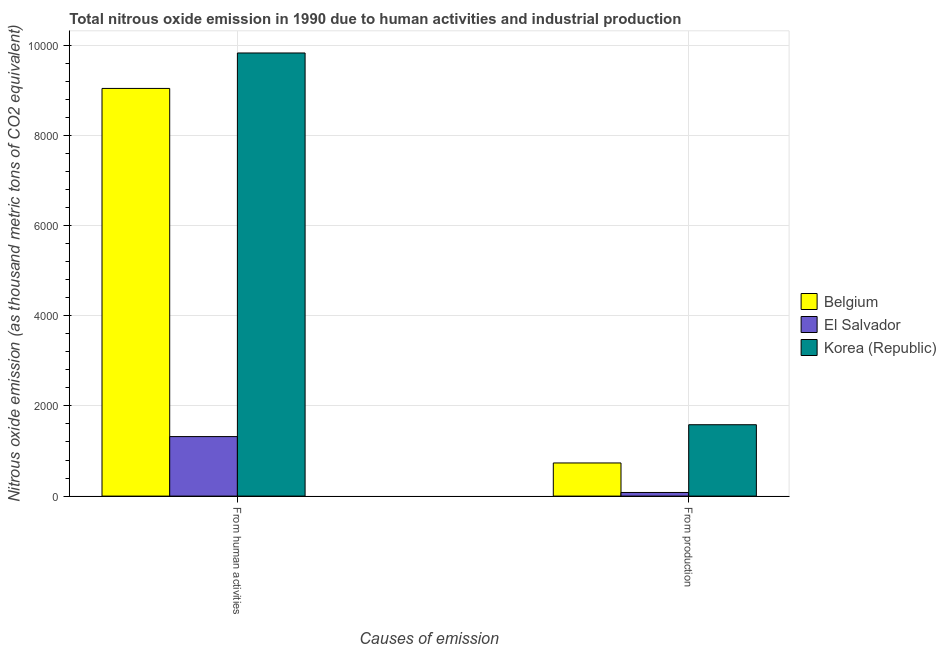How many different coloured bars are there?
Your response must be concise. 3. Are the number of bars on each tick of the X-axis equal?
Provide a succinct answer. Yes. What is the label of the 2nd group of bars from the left?
Provide a short and direct response. From production. What is the amount of emissions from human activities in El Salvador?
Offer a very short reply. 1319.4. Across all countries, what is the maximum amount of emissions from human activities?
Your answer should be very brief. 9823.4. Across all countries, what is the minimum amount of emissions generated from industries?
Offer a very short reply. 80.5. In which country was the amount of emissions from human activities minimum?
Provide a short and direct response. El Salvador. What is the total amount of emissions generated from industries in the graph?
Provide a short and direct response. 2398. What is the difference between the amount of emissions generated from industries in Belgium and that in El Salvador?
Give a very brief answer. 654.4. What is the difference between the amount of emissions generated from industries in Korea (Republic) and the amount of emissions from human activities in El Salvador?
Offer a very short reply. 263.2. What is the average amount of emissions generated from industries per country?
Keep it short and to the point. 799.33. What is the difference between the amount of emissions from human activities and amount of emissions generated from industries in Belgium?
Ensure brevity in your answer.  8302.8. What is the ratio of the amount of emissions generated from industries in Korea (Republic) to that in Belgium?
Ensure brevity in your answer.  2.15. In how many countries, is the amount of emissions from human activities greater than the average amount of emissions from human activities taken over all countries?
Provide a succinct answer. 2. What does the 3rd bar from the right in From human activities represents?
Make the answer very short. Belgium. Are all the bars in the graph horizontal?
Give a very brief answer. No. What is the difference between two consecutive major ticks on the Y-axis?
Make the answer very short. 2000. Are the values on the major ticks of Y-axis written in scientific E-notation?
Your answer should be compact. No. Does the graph contain any zero values?
Keep it short and to the point. No. How many legend labels are there?
Your response must be concise. 3. How are the legend labels stacked?
Your answer should be very brief. Vertical. What is the title of the graph?
Make the answer very short. Total nitrous oxide emission in 1990 due to human activities and industrial production. Does "Belarus" appear as one of the legend labels in the graph?
Keep it short and to the point. No. What is the label or title of the X-axis?
Make the answer very short. Causes of emission. What is the label or title of the Y-axis?
Provide a succinct answer. Nitrous oxide emission (as thousand metric tons of CO2 equivalent). What is the Nitrous oxide emission (as thousand metric tons of CO2 equivalent) of Belgium in From human activities?
Ensure brevity in your answer.  9037.7. What is the Nitrous oxide emission (as thousand metric tons of CO2 equivalent) of El Salvador in From human activities?
Your response must be concise. 1319.4. What is the Nitrous oxide emission (as thousand metric tons of CO2 equivalent) in Korea (Republic) in From human activities?
Ensure brevity in your answer.  9823.4. What is the Nitrous oxide emission (as thousand metric tons of CO2 equivalent) of Belgium in From production?
Ensure brevity in your answer.  734.9. What is the Nitrous oxide emission (as thousand metric tons of CO2 equivalent) of El Salvador in From production?
Your answer should be very brief. 80.5. What is the Nitrous oxide emission (as thousand metric tons of CO2 equivalent) in Korea (Republic) in From production?
Your answer should be very brief. 1582.6. Across all Causes of emission, what is the maximum Nitrous oxide emission (as thousand metric tons of CO2 equivalent) in Belgium?
Make the answer very short. 9037.7. Across all Causes of emission, what is the maximum Nitrous oxide emission (as thousand metric tons of CO2 equivalent) in El Salvador?
Offer a very short reply. 1319.4. Across all Causes of emission, what is the maximum Nitrous oxide emission (as thousand metric tons of CO2 equivalent) in Korea (Republic)?
Keep it short and to the point. 9823.4. Across all Causes of emission, what is the minimum Nitrous oxide emission (as thousand metric tons of CO2 equivalent) of Belgium?
Offer a very short reply. 734.9. Across all Causes of emission, what is the minimum Nitrous oxide emission (as thousand metric tons of CO2 equivalent) of El Salvador?
Your answer should be very brief. 80.5. Across all Causes of emission, what is the minimum Nitrous oxide emission (as thousand metric tons of CO2 equivalent) in Korea (Republic)?
Provide a succinct answer. 1582.6. What is the total Nitrous oxide emission (as thousand metric tons of CO2 equivalent) in Belgium in the graph?
Provide a succinct answer. 9772.6. What is the total Nitrous oxide emission (as thousand metric tons of CO2 equivalent) of El Salvador in the graph?
Offer a terse response. 1399.9. What is the total Nitrous oxide emission (as thousand metric tons of CO2 equivalent) in Korea (Republic) in the graph?
Your answer should be very brief. 1.14e+04. What is the difference between the Nitrous oxide emission (as thousand metric tons of CO2 equivalent) of Belgium in From human activities and that in From production?
Ensure brevity in your answer.  8302.8. What is the difference between the Nitrous oxide emission (as thousand metric tons of CO2 equivalent) in El Salvador in From human activities and that in From production?
Offer a terse response. 1238.9. What is the difference between the Nitrous oxide emission (as thousand metric tons of CO2 equivalent) of Korea (Republic) in From human activities and that in From production?
Make the answer very short. 8240.8. What is the difference between the Nitrous oxide emission (as thousand metric tons of CO2 equivalent) in Belgium in From human activities and the Nitrous oxide emission (as thousand metric tons of CO2 equivalent) in El Salvador in From production?
Your response must be concise. 8957.2. What is the difference between the Nitrous oxide emission (as thousand metric tons of CO2 equivalent) in Belgium in From human activities and the Nitrous oxide emission (as thousand metric tons of CO2 equivalent) in Korea (Republic) in From production?
Provide a succinct answer. 7455.1. What is the difference between the Nitrous oxide emission (as thousand metric tons of CO2 equivalent) in El Salvador in From human activities and the Nitrous oxide emission (as thousand metric tons of CO2 equivalent) in Korea (Republic) in From production?
Your answer should be very brief. -263.2. What is the average Nitrous oxide emission (as thousand metric tons of CO2 equivalent) in Belgium per Causes of emission?
Give a very brief answer. 4886.3. What is the average Nitrous oxide emission (as thousand metric tons of CO2 equivalent) of El Salvador per Causes of emission?
Your answer should be very brief. 699.95. What is the average Nitrous oxide emission (as thousand metric tons of CO2 equivalent) in Korea (Republic) per Causes of emission?
Provide a short and direct response. 5703. What is the difference between the Nitrous oxide emission (as thousand metric tons of CO2 equivalent) in Belgium and Nitrous oxide emission (as thousand metric tons of CO2 equivalent) in El Salvador in From human activities?
Provide a short and direct response. 7718.3. What is the difference between the Nitrous oxide emission (as thousand metric tons of CO2 equivalent) in Belgium and Nitrous oxide emission (as thousand metric tons of CO2 equivalent) in Korea (Republic) in From human activities?
Offer a terse response. -785.7. What is the difference between the Nitrous oxide emission (as thousand metric tons of CO2 equivalent) in El Salvador and Nitrous oxide emission (as thousand metric tons of CO2 equivalent) in Korea (Republic) in From human activities?
Give a very brief answer. -8504. What is the difference between the Nitrous oxide emission (as thousand metric tons of CO2 equivalent) in Belgium and Nitrous oxide emission (as thousand metric tons of CO2 equivalent) in El Salvador in From production?
Offer a terse response. 654.4. What is the difference between the Nitrous oxide emission (as thousand metric tons of CO2 equivalent) of Belgium and Nitrous oxide emission (as thousand metric tons of CO2 equivalent) of Korea (Republic) in From production?
Make the answer very short. -847.7. What is the difference between the Nitrous oxide emission (as thousand metric tons of CO2 equivalent) in El Salvador and Nitrous oxide emission (as thousand metric tons of CO2 equivalent) in Korea (Republic) in From production?
Provide a succinct answer. -1502.1. What is the ratio of the Nitrous oxide emission (as thousand metric tons of CO2 equivalent) of Belgium in From human activities to that in From production?
Give a very brief answer. 12.3. What is the ratio of the Nitrous oxide emission (as thousand metric tons of CO2 equivalent) in El Salvador in From human activities to that in From production?
Your answer should be very brief. 16.39. What is the ratio of the Nitrous oxide emission (as thousand metric tons of CO2 equivalent) of Korea (Republic) in From human activities to that in From production?
Your answer should be very brief. 6.21. What is the difference between the highest and the second highest Nitrous oxide emission (as thousand metric tons of CO2 equivalent) of Belgium?
Your response must be concise. 8302.8. What is the difference between the highest and the second highest Nitrous oxide emission (as thousand metric tons of CO2 equivalent) in El Salvador?
Offer a terse response. 1238.9. What is the difference between the highest and the second highest Nitrous oxide emission (as thousand metric tons of CO2 equivalent) of Korea (Republic)?
Offer a terse response. 8240.8. What is the difference between the highest and the lowest Nitrous oxide emission (as thousand metric tons of CO2 equivalent) in Belgium?
Your answer should be very brief. 8302.8. What is the difference between the highest and the lowest Nitrous oxide emission (as thousand metric tons of CO2 equivalent) in El Salvador?
Provide a succinct answer. 1238.9. What is the difference between the highest and the lowest Nitrous oxide emission (as thousand metric tons of CO2 equivalent) of Korea (Republic)?
Give a very brief answer. 8240.8. 